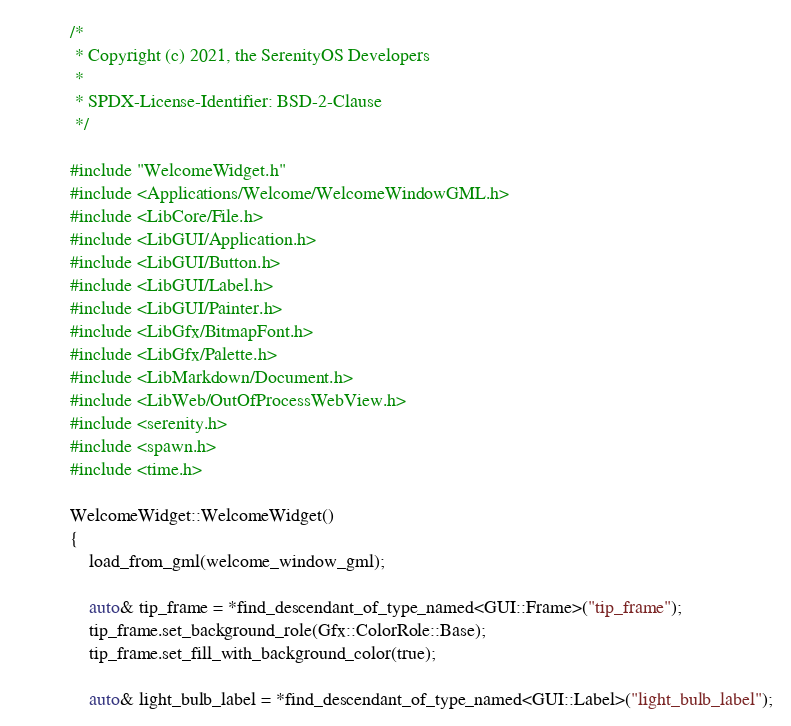<code> <loc_0><loc_0><loc_500><loc_500><_C++_>/*
 * Copyright (c) 2021, the SerenityOS Developers
 *
 * SPDX-License-Identifier: BSD-2-Clause
 */

#include "WelcomeWidget.h"
#include <Applications/Welcome/WelcomeWindowGML.h>
#include <LibCore/File.h>
#include <LibGUI/Application.h>
#include <LibGUI/Button.h>
#include <LibGUI/Label.h>
#include <LibGUI/Painter.h>
#include <LibGfx/BitmapFont.h>
#include <LibGfx/Palette.h>
#include <LibMarkdown/Document.h>
#include <LibWeb/OutOfProcessWebView.h>
#include <serenity.h>
#include <spawn.h>
#include <time.h>

WelcomeWidget::WelcomeWidget()
{
    load_from_gml(welcome_window_gml);

    auto& tip_frame = *find_descendant_of_type_named<GUI::Frame>("tip_frame");
    tip_frame.set_background_role(Gfx::ColorRole::Base);
    tip_frame.set_fill_with_background_color(true);

    auto& light_bulb_label = *find_descendant_of_type_named<GUI::Label>("light_bulb_label");</code> 